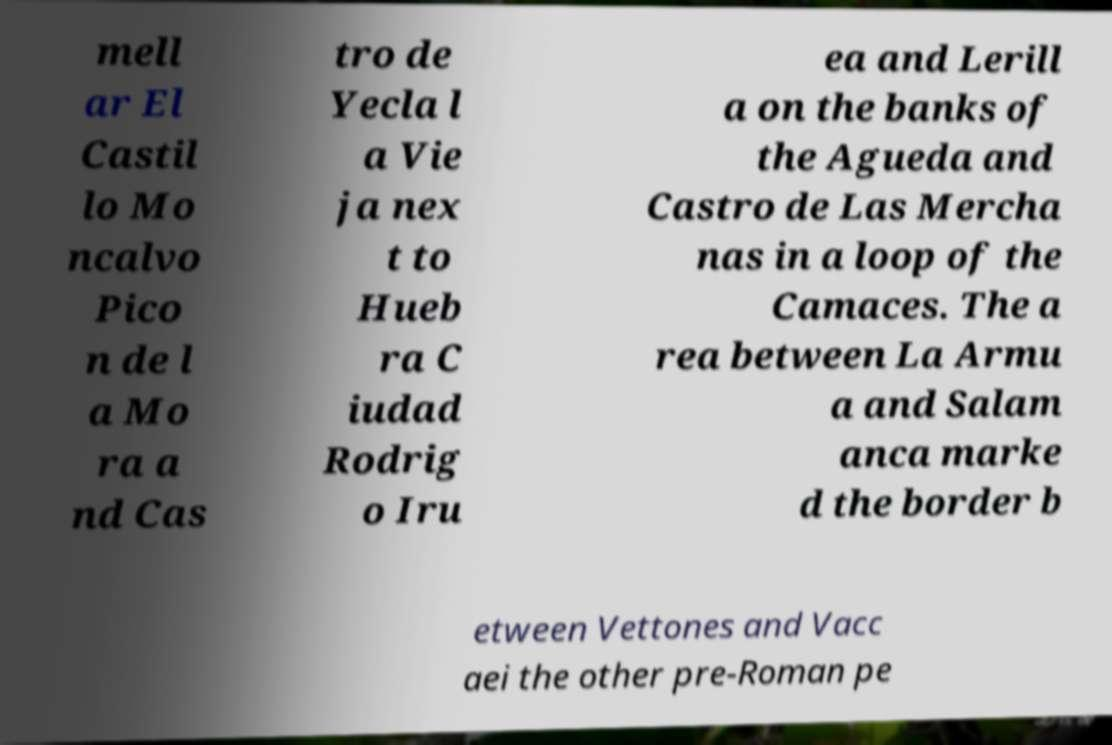I need the written content from this picture converted into text. Can you do that? mell ar El Castil lo Mo ncalvo Pico n de l a Mo ra a nd Cas tro de Yecla l a Vie ja nex t to Hueb ra C iudad Rodrig o Iru ea and Lerill a on the banks of the Agueda and Castro de Las Mercha nas in a loop of the Camaces. The a rea between La Armu a and Salam anca marke d the border b etween Vettones and Vacc aei the other pre-Roman pe 